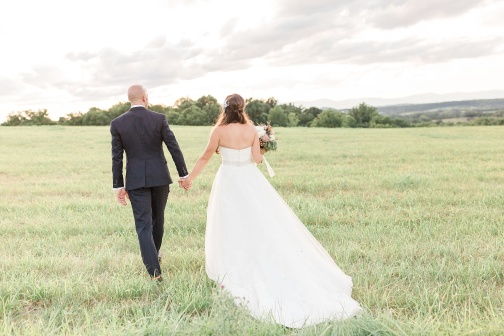If you could give a title to this image, what would it be? Embarking on Forever: The First Steps 